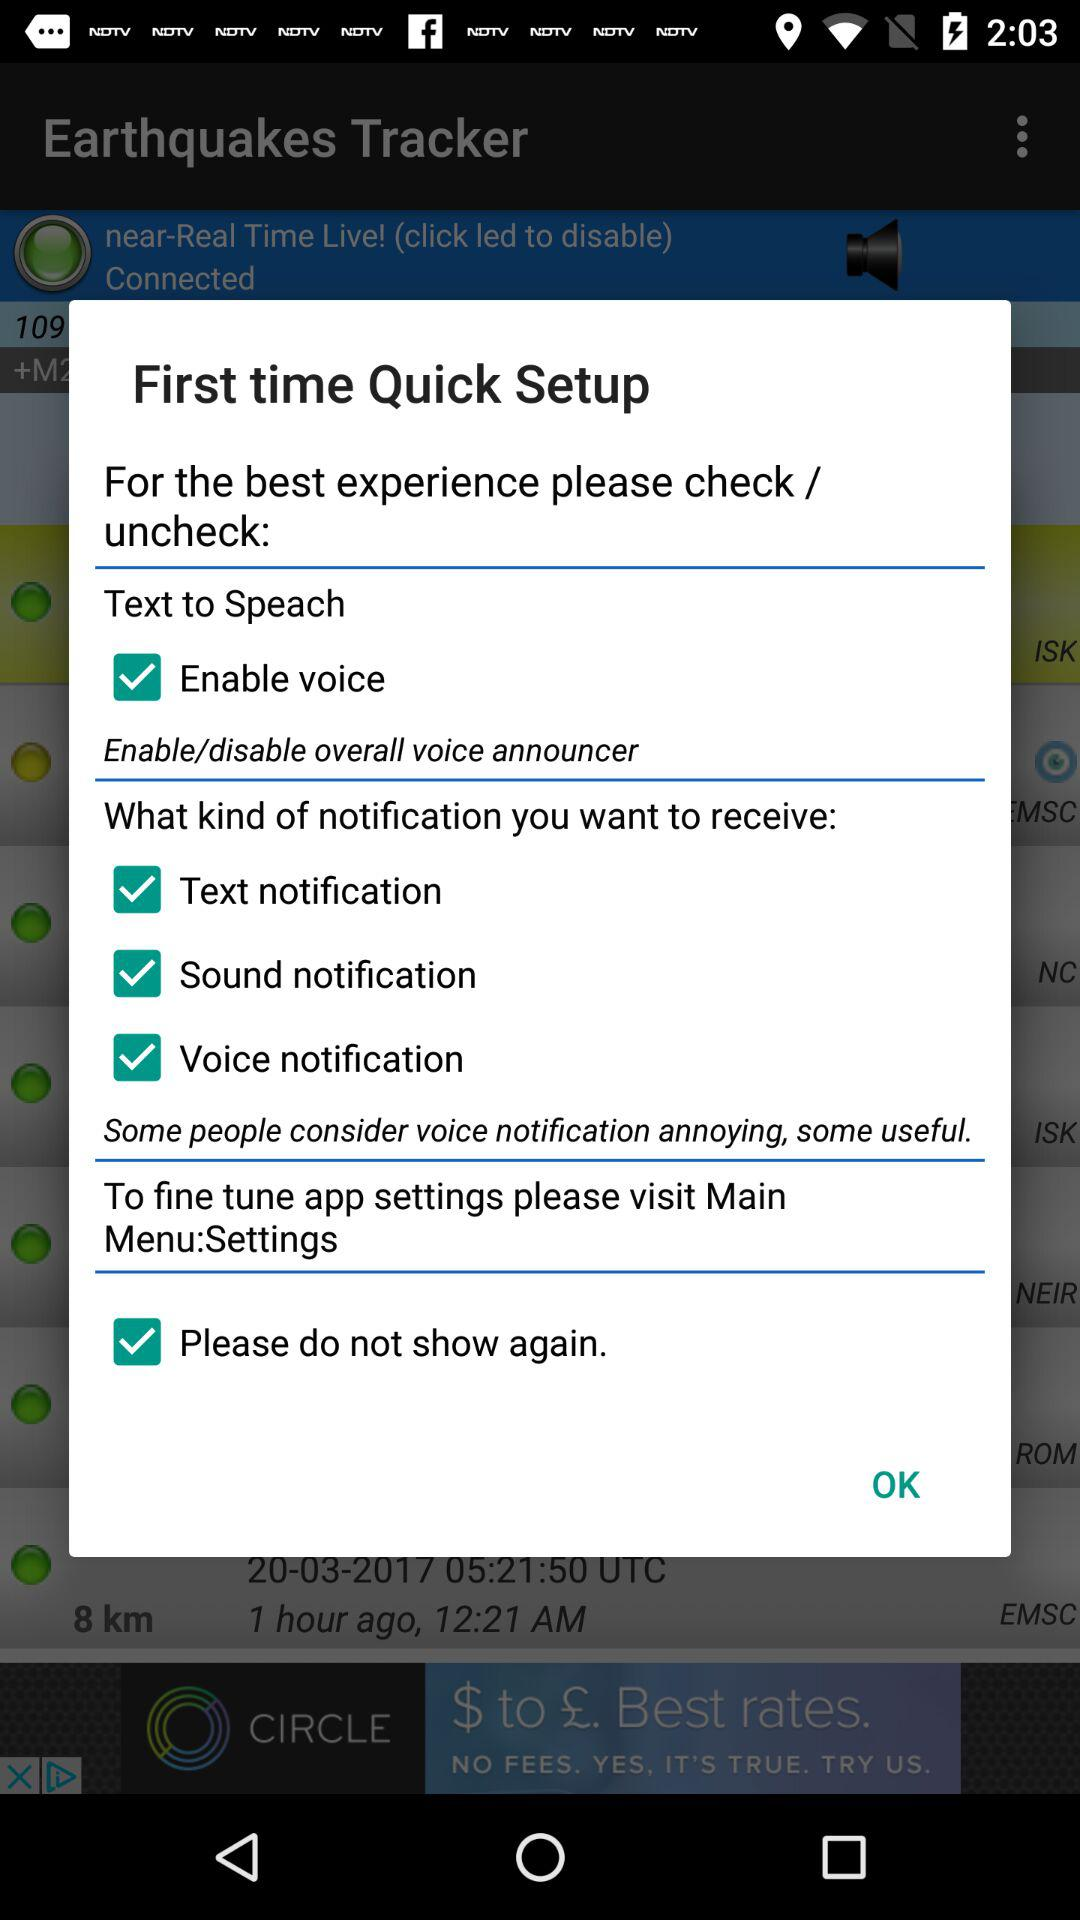What check box is checked in "Text to Speach"? The checked box is "Enable voice". 